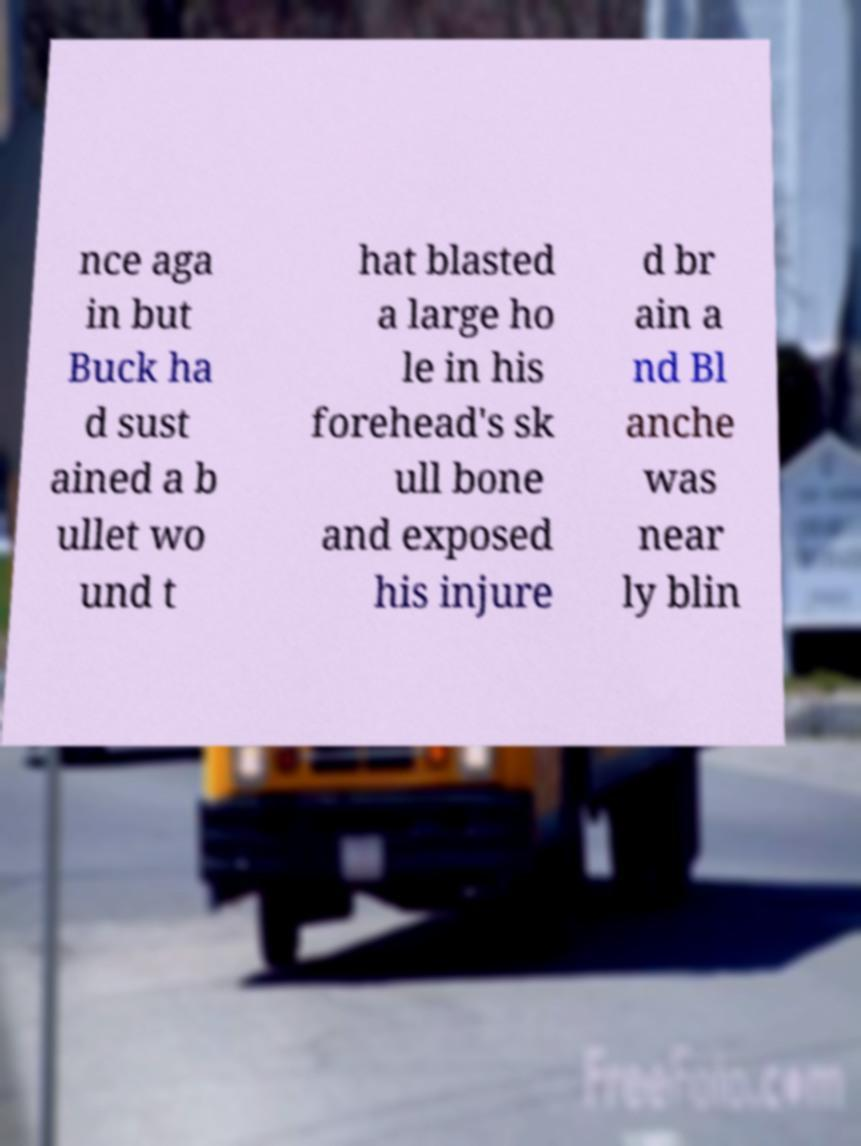Can you read and provide the text displayed in the image?This photo seems to have some interesting text. Can you extract and type it out for me? nce aga in but Buck ha d sust ained a b ullet wo und t hat blasted a large ho le in his forehead's sk ull bone and exposed his injure d br ain a nd Bl anche was near ly blin 